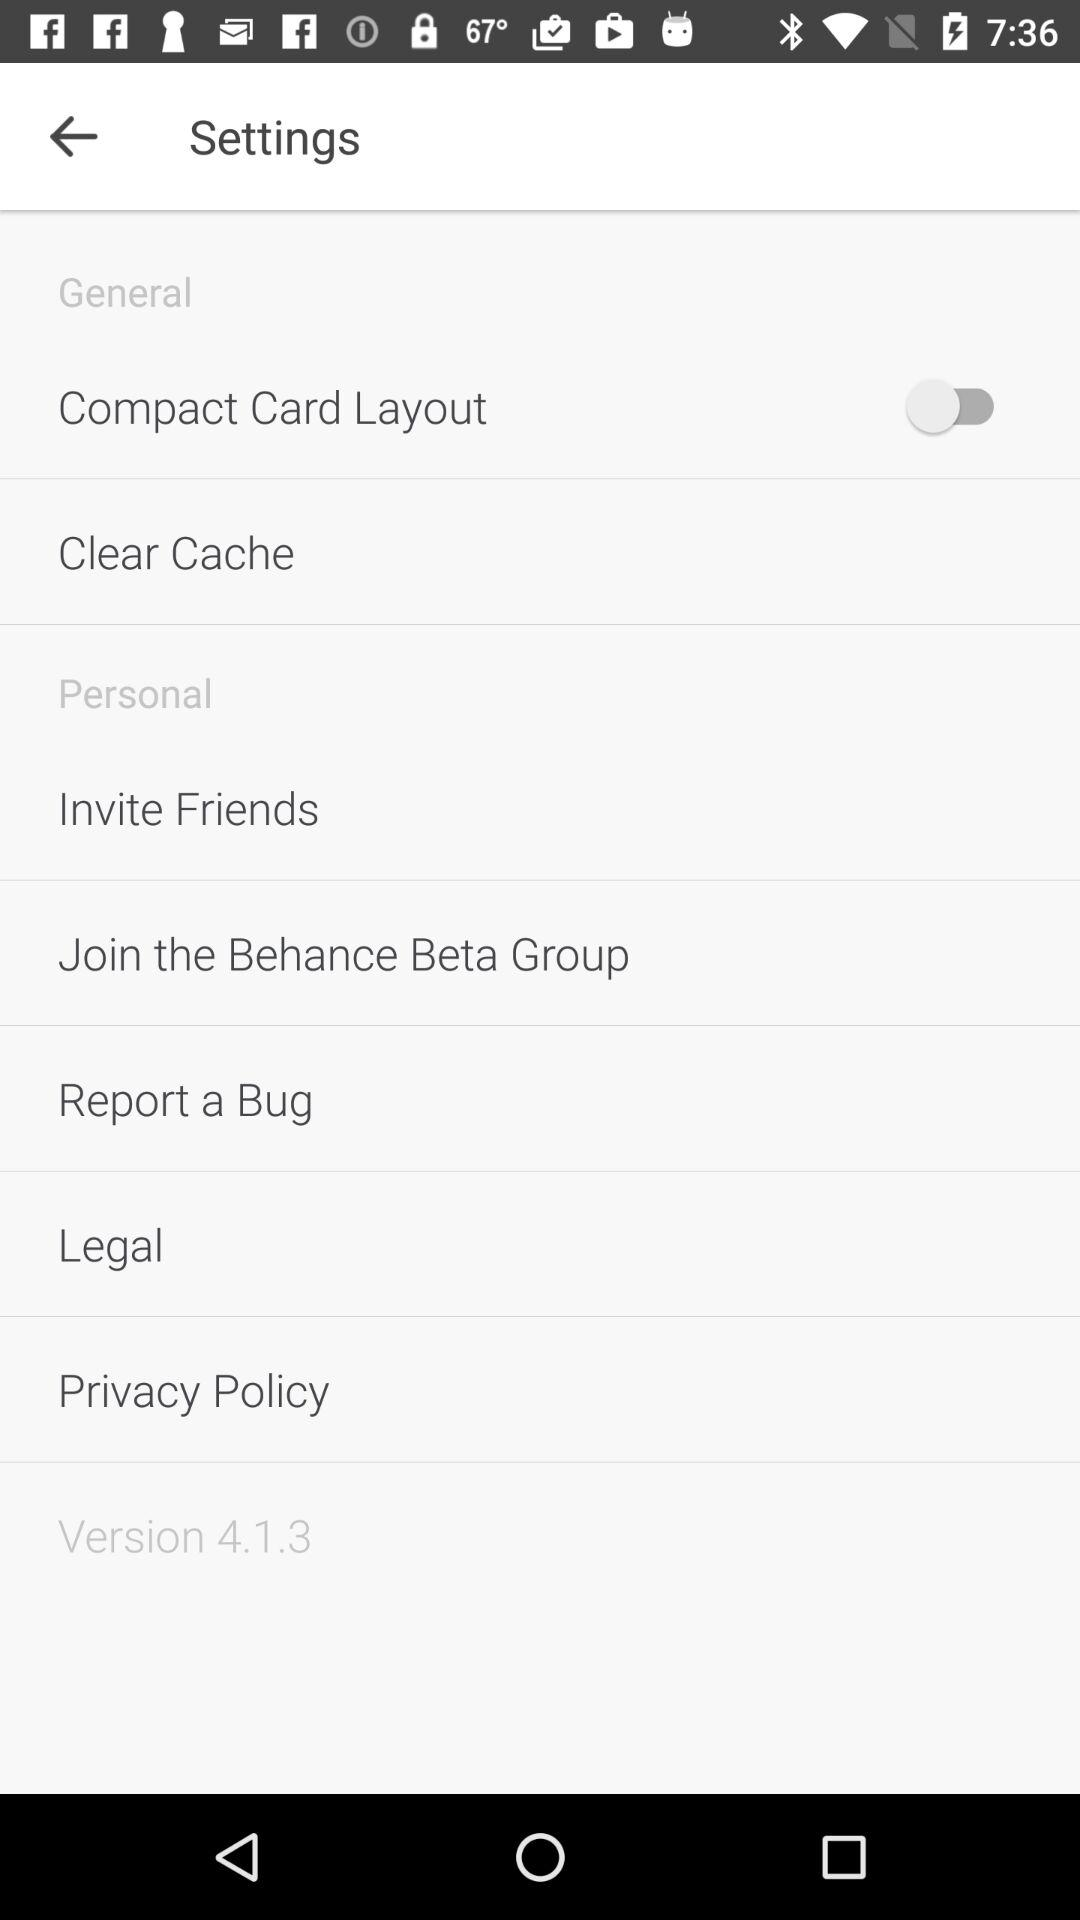What is the version? The version is 4.1.3. 